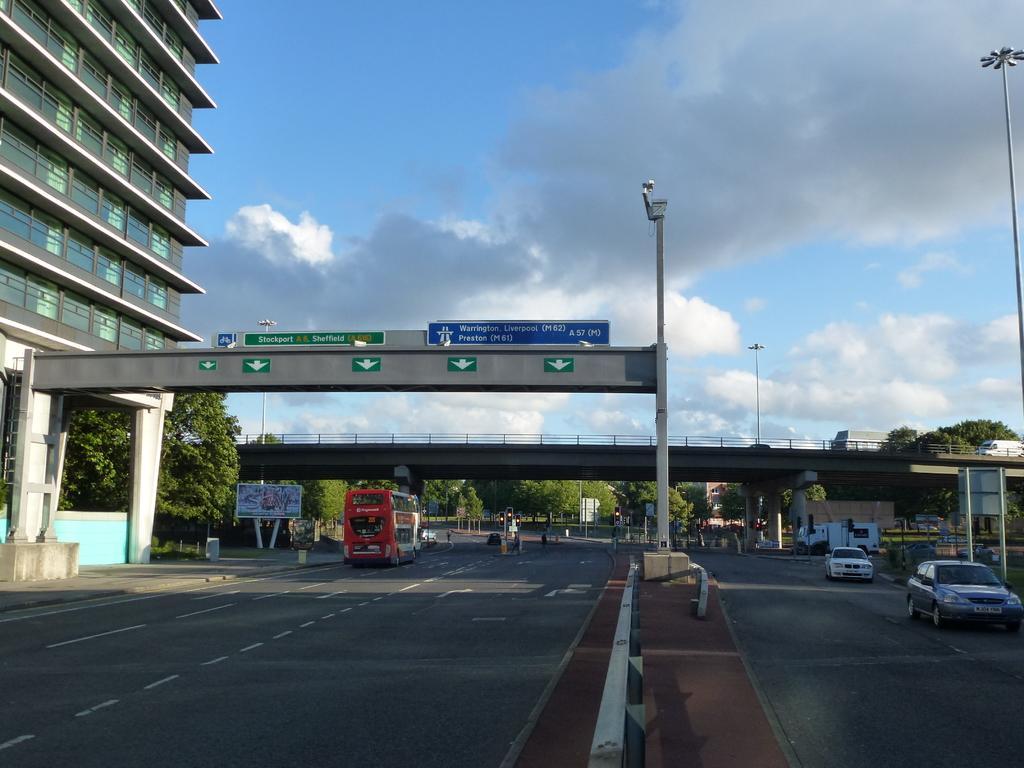Could you give a brief overview of what you see in this image? At the bottom of the image there are road with vehicles. And also there is a divider with light pole. And also there is a pillar with sign boards. In the background there is a bridge with railings and pillars. And also there are trees, poles with sign boards and posters. In the top left corner of the image there is a building with glasses. At the top of the image there is sky with clouds. 